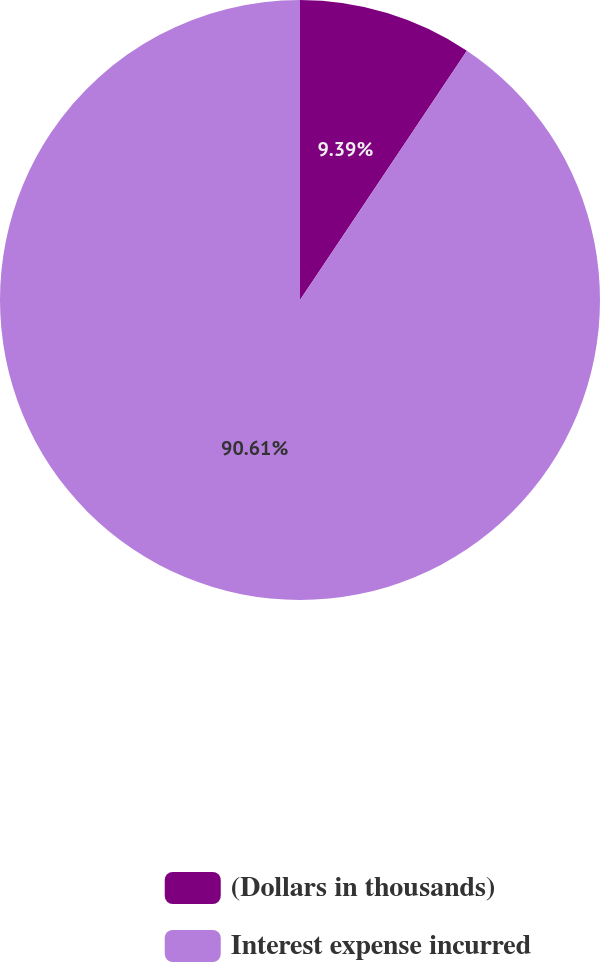Convert chart. <chart><loc_0><loc_0><loc_500><loc_500><pie_chart><fcel>(Dollars in thousands)<fcel>Interest expense incurred<nl><fcel>9.39%<fcel>90.61%<nl></chart> 